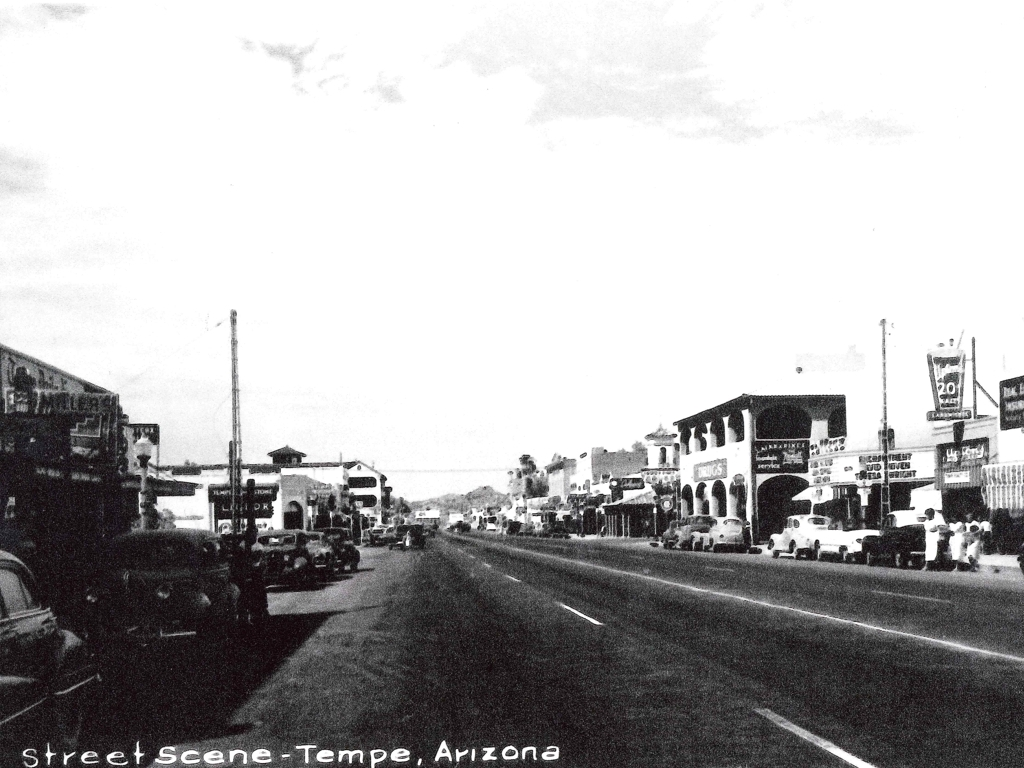Can you tell me what era this photo might be from based on the cars and architecture? The vehicles and building styles suggest this photograph was likely taken in the mid-20th century, possibly around the 1940s or 1950s. The cars have a classic, vintage design prevalent during that era, and the architecture shows the art-deco and modernist influences of the time. 